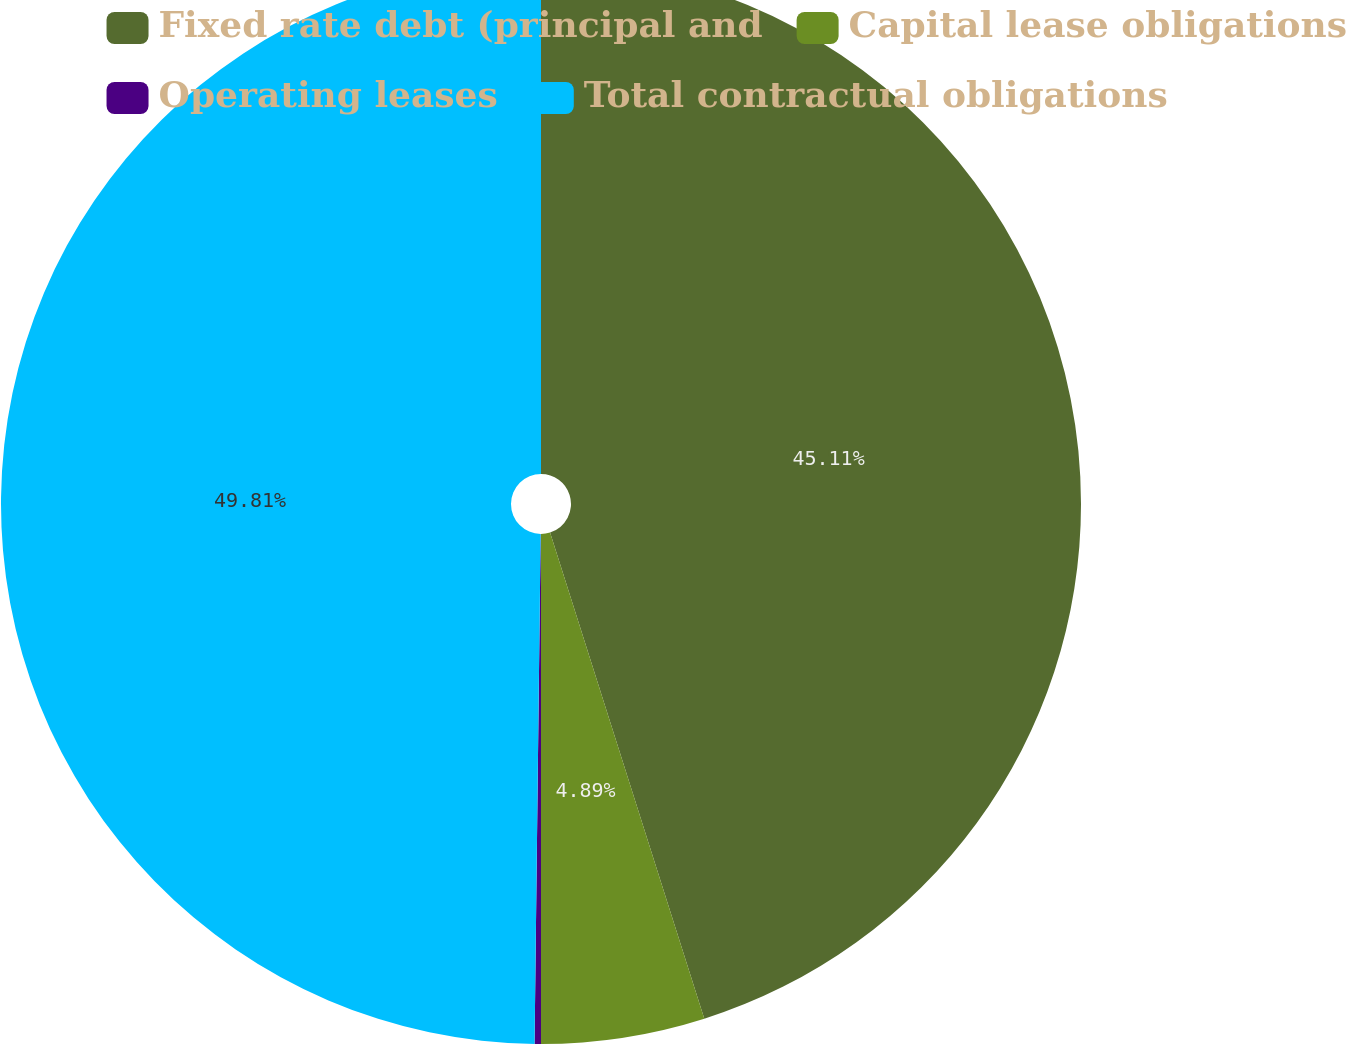<chart> <loc_0><loc_0><loc_500><loc_500><pie_chart><fcel>Fixed rate debt (principal and<fcel>Capital lease obligations<fcel>Operating leases<fcel>Total contractual obligations<nl><fcel>45.11%<fcel>4.89%<fcel>0.19%<fcel>49.81%<nl></chart> 